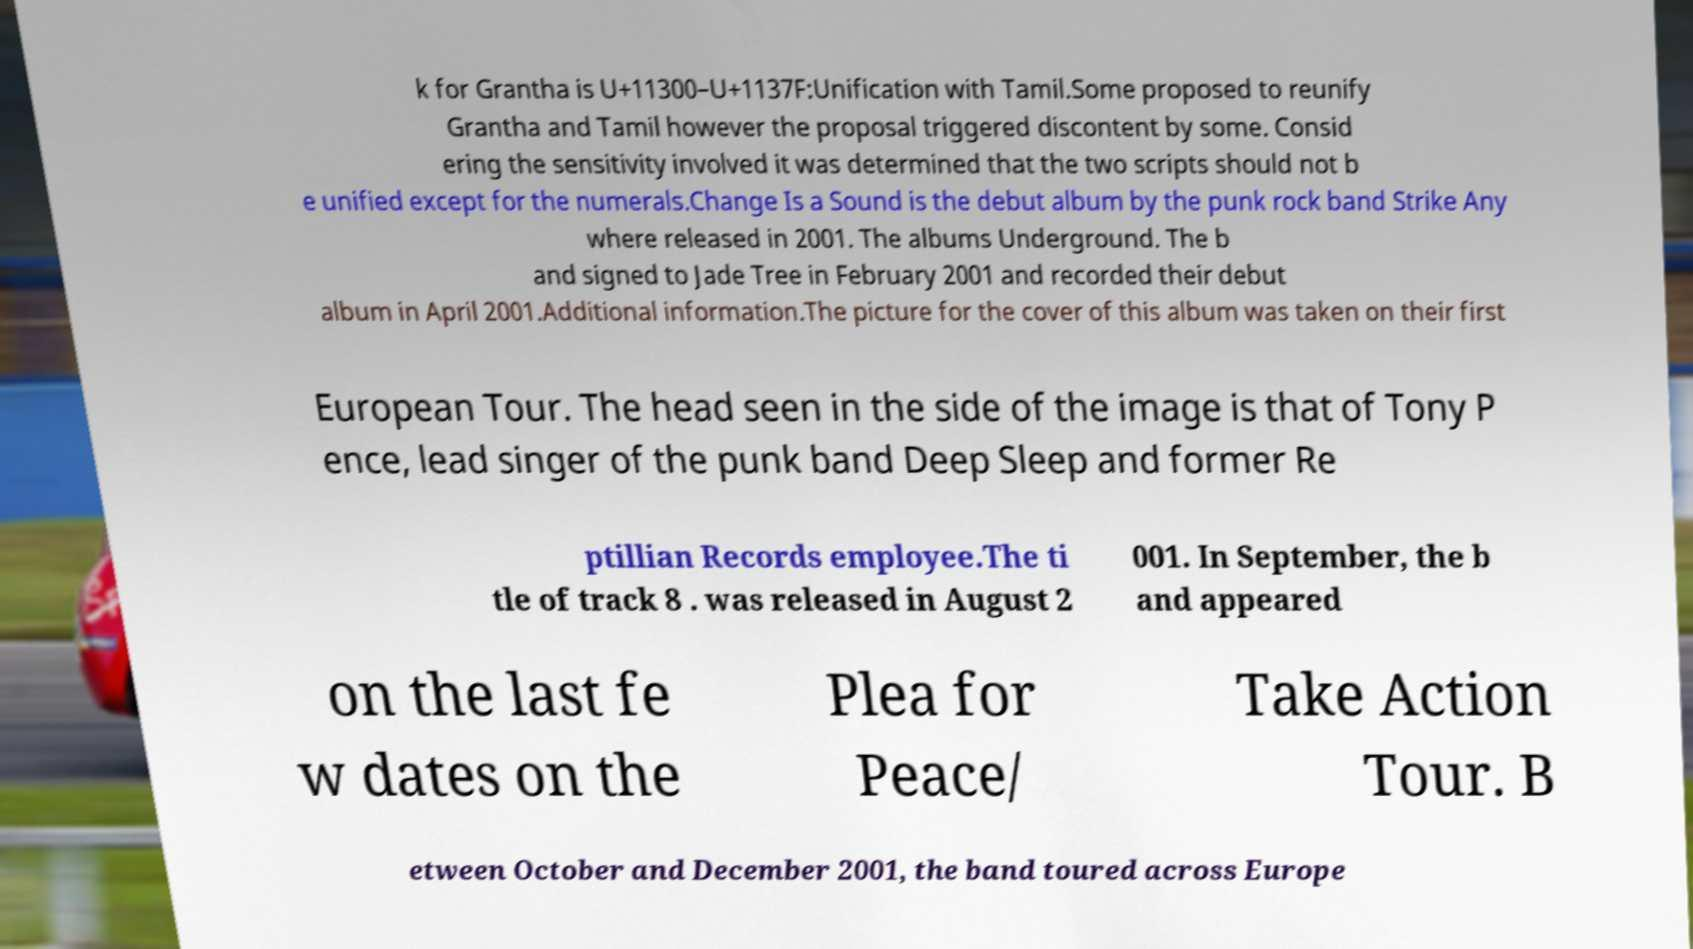For documentation purposes, I need the text within this image transcribed. Could you provide that? k for Grantha is U+11300–U+1137F:Unification with Tamil.Some proposed to reunify Grantha and Tamil however the proposal triggered discontent by some. Consid ering the sensitivity involved it was determined that the two scripts should not b e unified except for the numerals.Change Is a Sound is the debut album by the punk rock band Strike Any where released in 2001. The albums Underground. The b and signed to Jade Tree in February 2001 and recorded their debut album in April 2001.Additional information.The picture for the cover of this album was taken on their first European Tour. The head seen in the side of the image is that of Tony P ence, lead singer of the punk band Deep Sleep and former Re ptillian Records employee.The ti tle of track 8 . was released in August 2 001. In September, the b and appeared on the last fe w dates on the Plea for Peace/ Take Action Tour. B etween October and December 2001, the band toured across Europe 